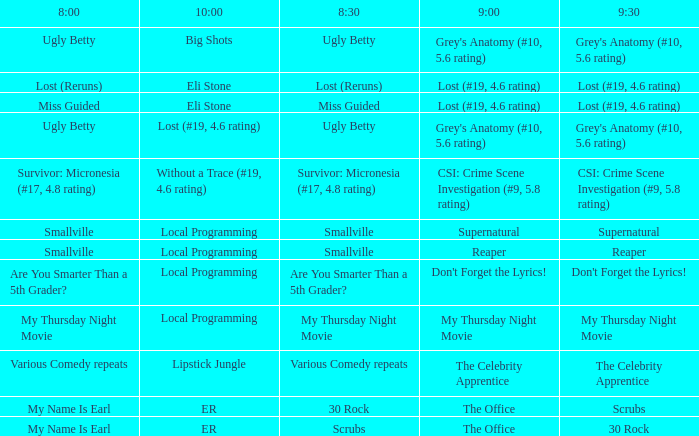What is at 10:00 when at 9:00 it is reaper? Local Programming. 